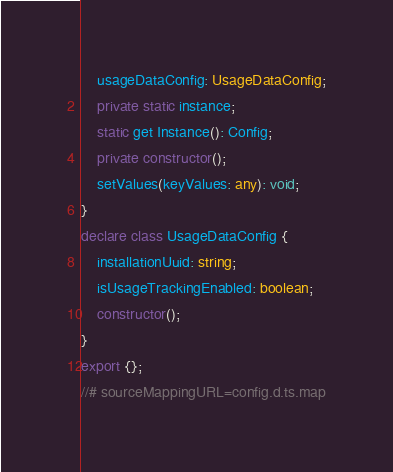Convert code to text. <code><loc_0><loc_0><loc_500><loc_500><_TypeScript_>    usageDataConfig: UsageDataConfig;
    private static instance;
    static get Instance(): Config;
    private constructor();
    setValues(keyValues: any): void;
}
declare class UsageDataConfig {
    installationUuid: string;
    isUsageTrackingEnabled: boolean;
    constructor();
}
export {};
//# sourceMappingURL=config.d.ts.map</code> 